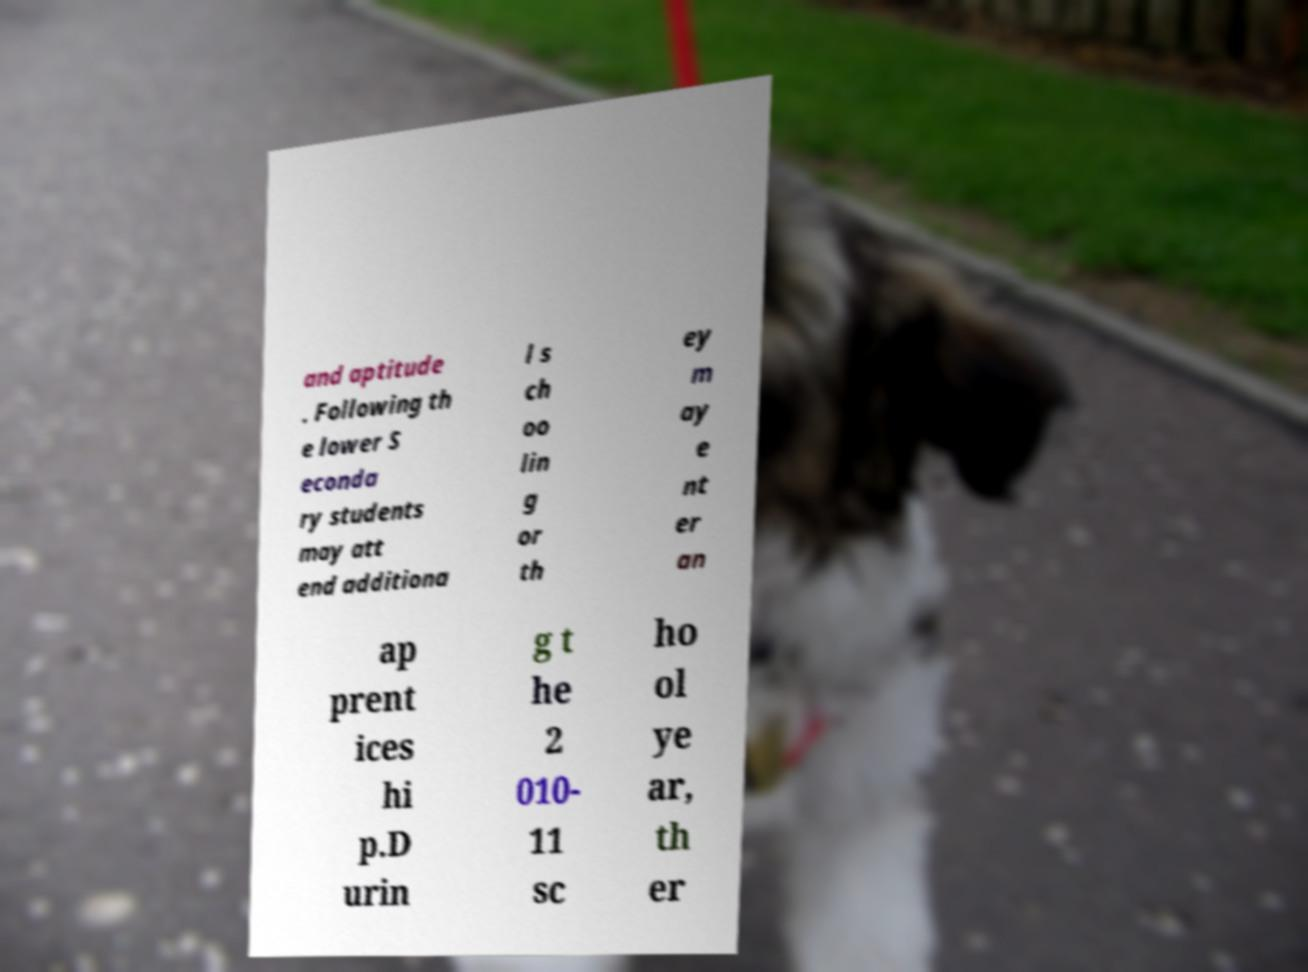Please read and relay the text visible in this image. What does it say? and aptitude . Following th e lower S econda ry students may att end additiona l s ch oo lin g or th ey m ay e nt er an ap prent ices hi p.D urin g t he 2 010- 11 sc ho ol ye ar, th er 